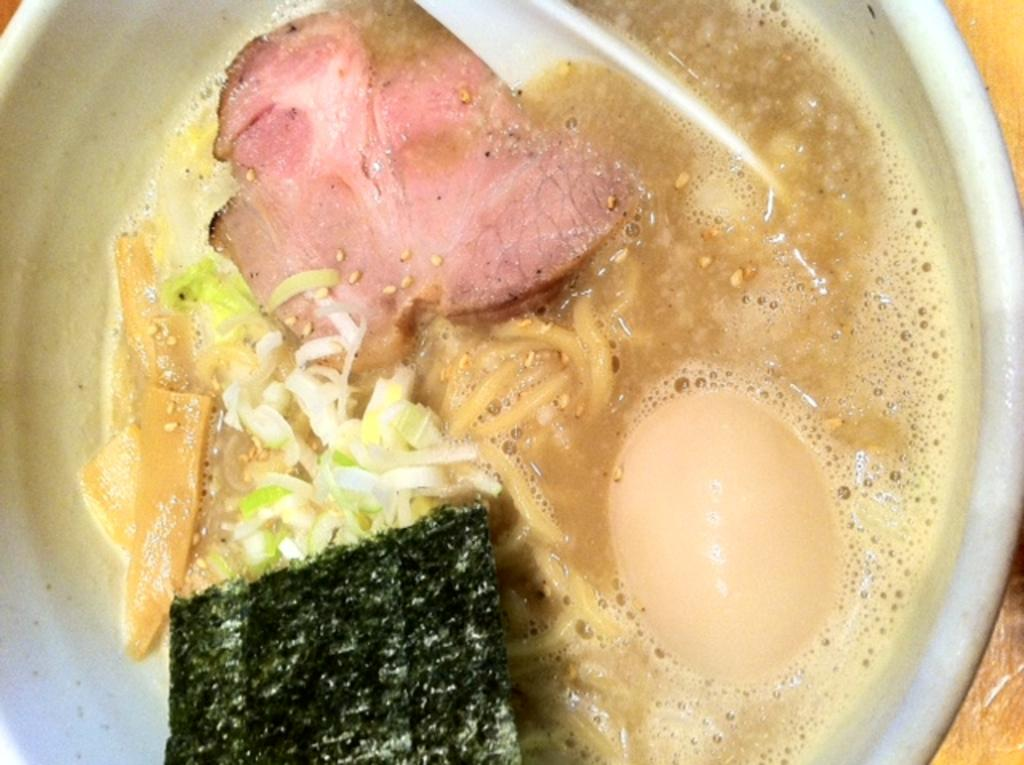What is in the bowl that is visible in the image? The bowl contains a spoon, an egg, soup, noodles, meat, and a few other things. What is the purpose of the spoon in the bowl? The spoon is likely used for stirring or eating the contents of the bowl. What type of dish might the bowl contain, given the presence of soup, noodles, and meat? The bowl contains a type of soup or stew with noodles and meat. Where is the bowl located in the image? The bowl is placed on a table. What type of art can be seen hanging on the wall behind the table in the image? There is no art visible on the wall behind the table in the image. What type of pin is used to hold the napkin in place on the table in the image? There is no pin visible on the table in the image. 